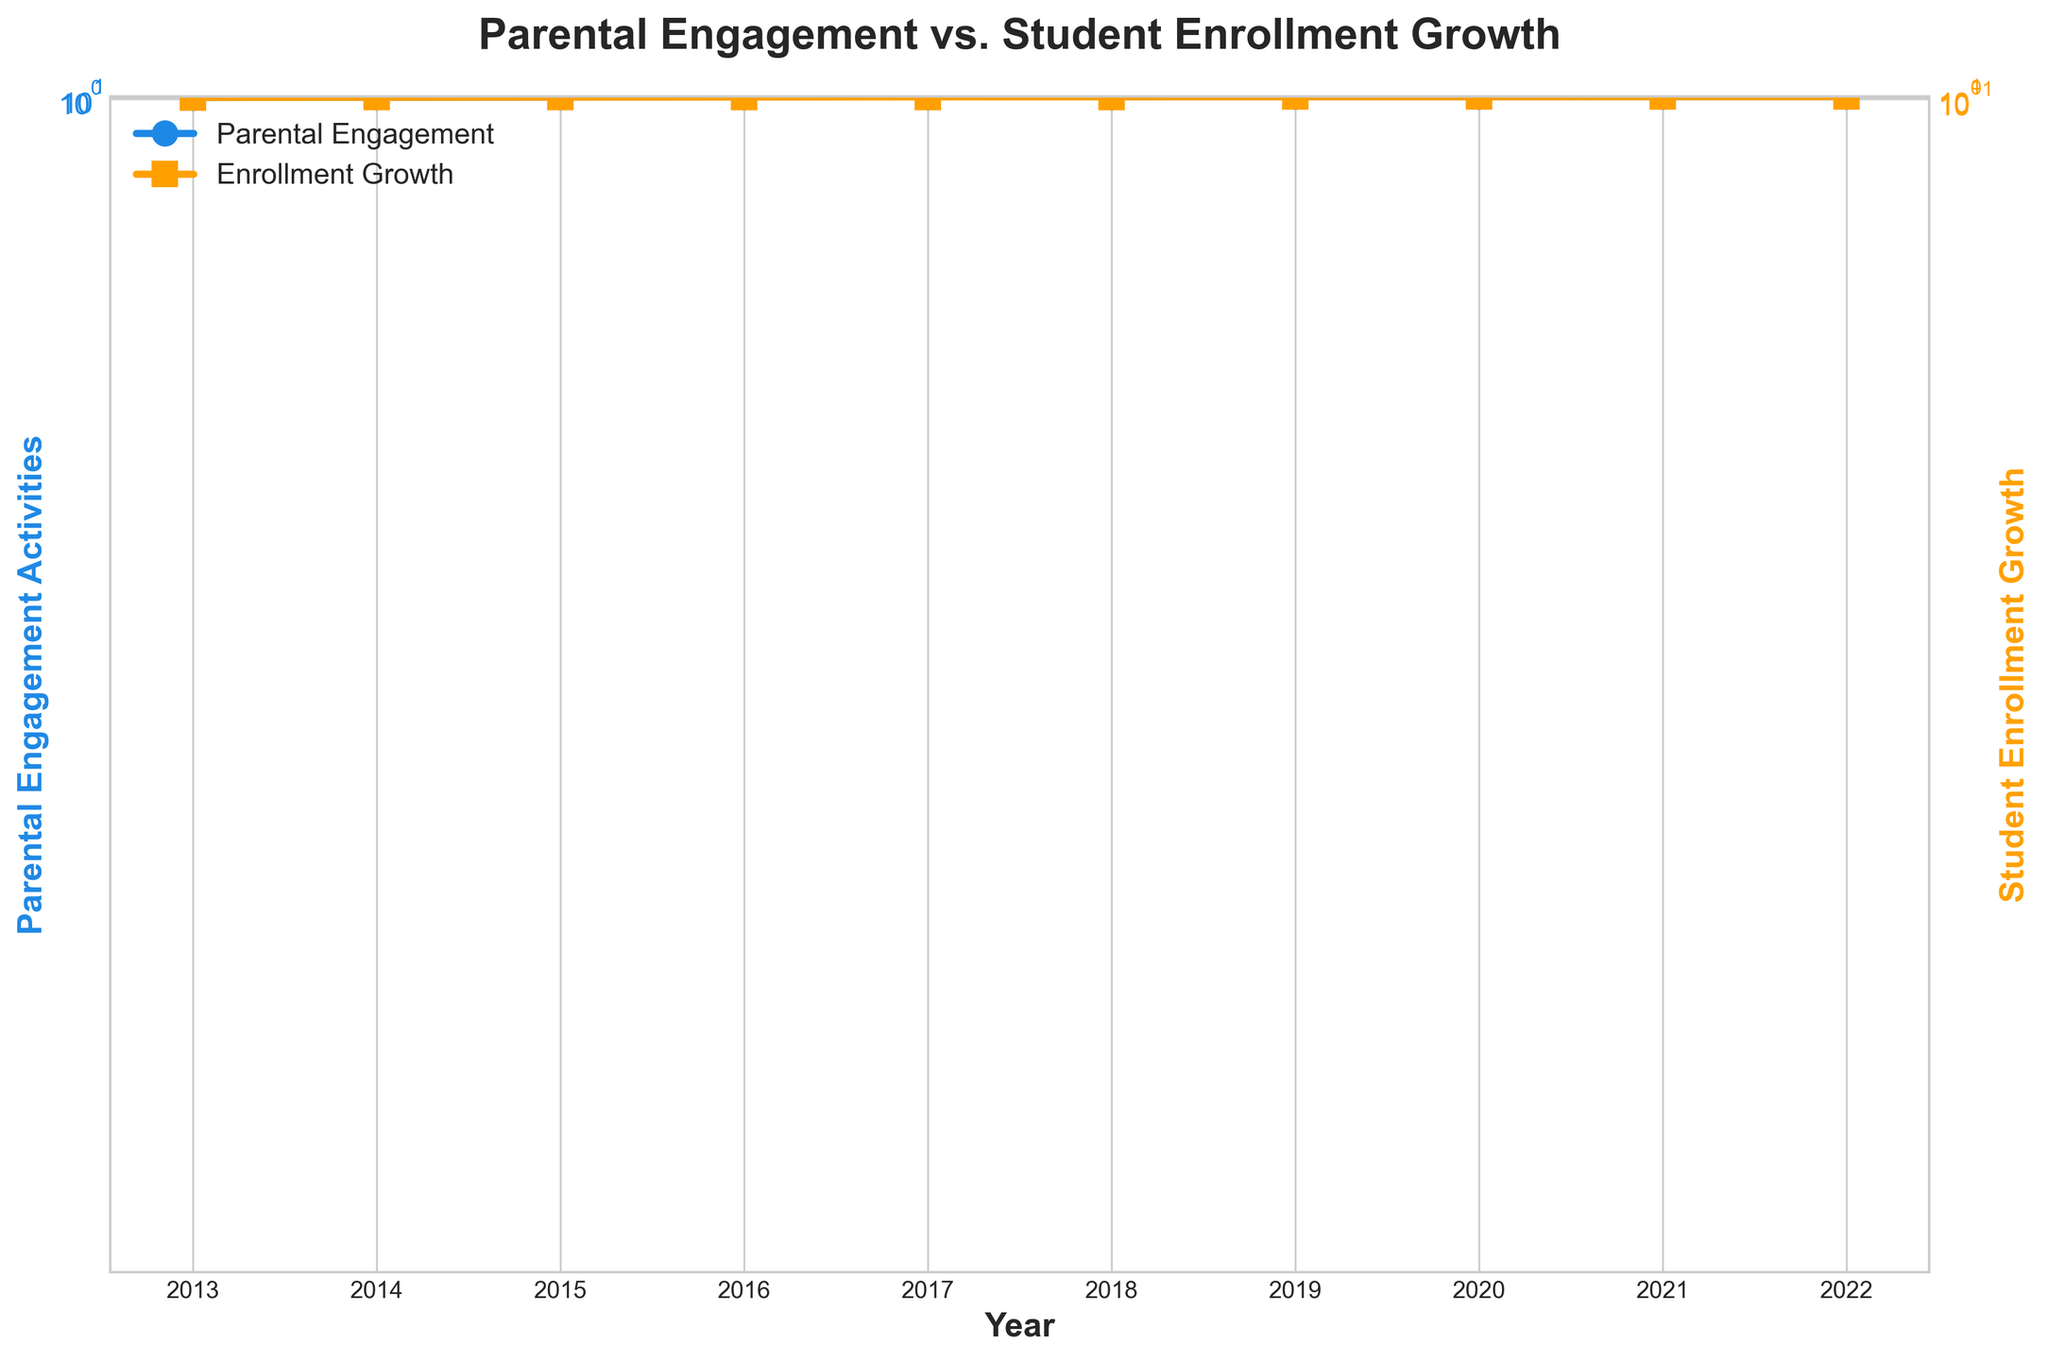How many years of data are presented in the figure? The figure provides data spanning from 2013 to 2022. This can be counted by considering each year listed on the x-axis.
Answer: 10 years What is the title of the figure? The title of the figure is written at the top of the plot. It reads 'Parental Engagement vs. Student Enrollment Growth.'
Answer: Parental Engagement vs. Student Enrollment Growth Describe the trend in Parental Engagement Activities over the years. The blue line depicting Parental Engagement Activities shows an initial increase from 2013 to 2019, a slight dip in 2020, and continues to rise gradually thereafter. This is evident by tracing the line and noting its general upward direction, except for the dip.
Answer: Mostly increasing with a slight dip in 2020 In which year did Student Enrollment Growth first reach 20? Observing the orange line representing Student Enrollment Growth, we see that it first intersects the 20-unit mark in 2018.
Answer: 2018 Compare the Parental Engagement Activities in 2019 to those in 2020. By looking at the blue line and reading its value at the respective years, Parental Engagement Activities were at 60 in 2019 and dropped to 55 in 2020.
Answer: 60 in 2019, dropped to 55 in 2020 Which year had the largest gap between Parental Engagement Activities and Student Enrollment Growth? To determine this, compare the values of both metrics year by year and identify the largest difference. The gap is largest in 2019, with Parental Engagement Activities at 60 and Student Enrollment Growth at 25, a difference of 35.
Answer: 2019 What can you say about the correlation between Parental Engagement Activities and Student Enrollment Growth based on the plot? Both metrics generally increase over the years, showing a positive correlation. Despite some minor variability, the general trend is that as Parental Engagement Activities increase, Student Enrollment Growth also increases.
Answer: Positive correlation How did Student Enrollment Growth respond to the dip in Parental Engagement Activities in 2020? Reviewing the lines, Student Enrollment Growth slightly decreased in 2020 from 25 to 23, which corresponds with the dip in Parental Engagement Activities (from 60 to 55).
Answer: Slight decrease Calculate the average of Student Enrollment Growth over the years shown. The values given are 5, 7, 10, 12, 15, 20, 25, 23, 28, and 30. Adding these together gets 175. Dividing by the 10 years results in an average of 17.5.
Answer: 17.5 